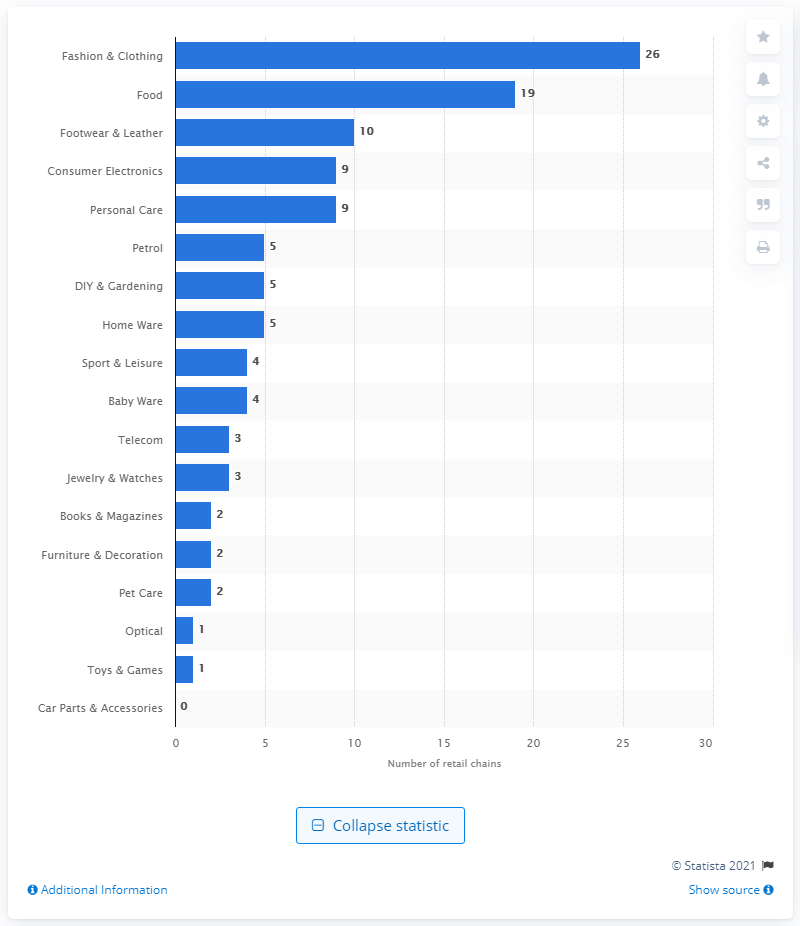Point out several critical features in this image. In 2020, there were 19 retail chains in Ukraine that specialized in food products. 